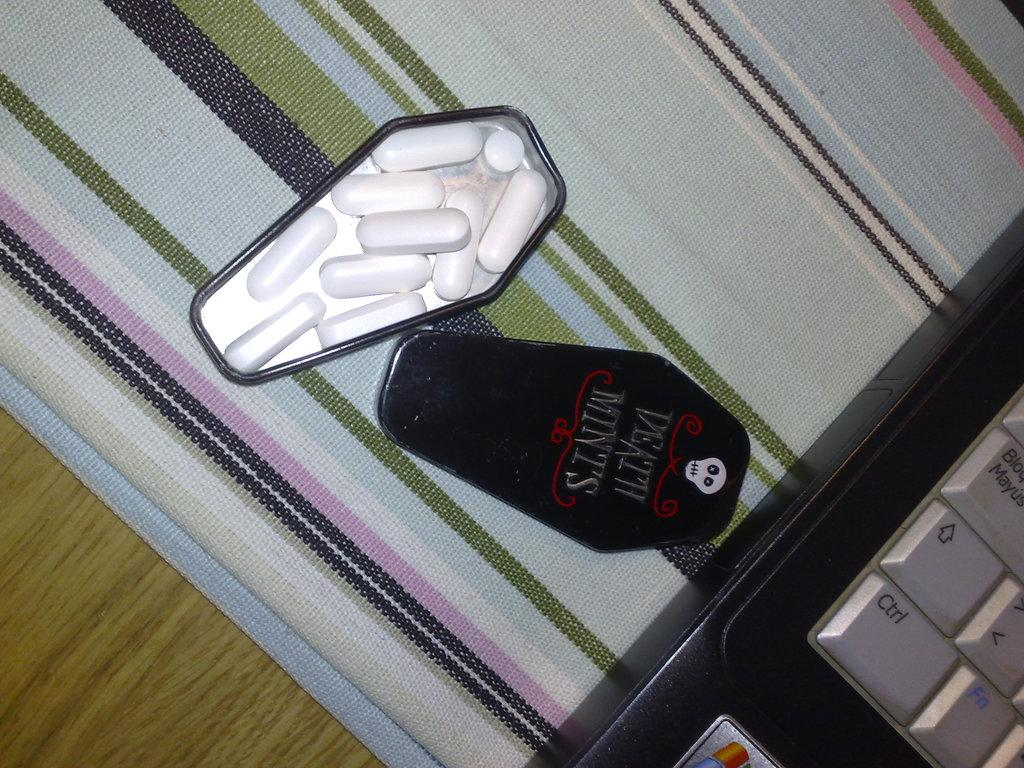<image>
Present a compact description of the photo's key features. An opened coffin shaped tin for Death MInts lays on a striped cloth. 